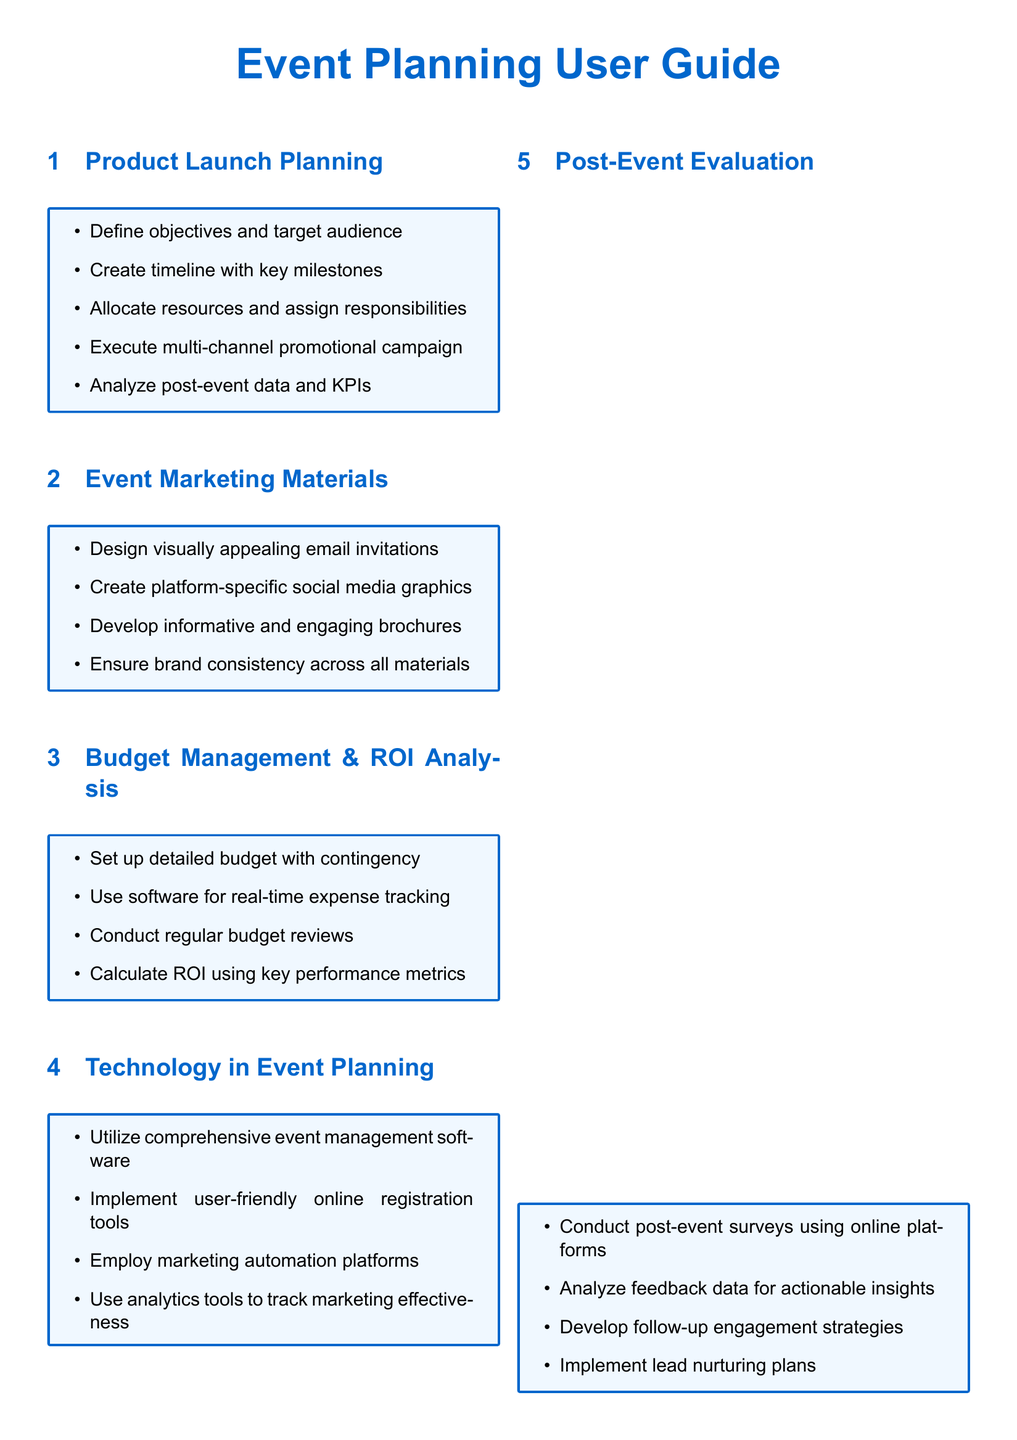What are the critical phases of planning a product launch event? The critical phases include defining objectives and target audience, creating a timeline with key milestones, allocating resources and assigning responsibilities, executing a multi-channel promotional campaign, and analyzing post-event data and KPIs.
Answer: Define objectives and target audience, create timeline with key milestones, allocate resources and assign responsibilities, execute multi-channel promotional campaign, analyze post-event data and KPIs What should be included in effective event marketing materials? Effective event marketing materials should include visually appealing email invitations, platform-specific social media graphics, informative brochures, and ensure brand consistency across all materials.
Answer: Visually appealing email invitations, platform-specific social media graphics, informative brochures, brand consistency What is a key aspect of budget management for corporate events? A key aspect of budget management is setting up a detailed budget with contingencies to manage unexpected expenses.
Answer: Setting up a detailed budget with contingency Which software tools can enhance event planning? Comprehensive event management software, user-friendly online registration tools, marketing automation platforms, and analytics tools are useful for enhancing event planning.
Answer: Comprehensive event management software, user-friendly online registration tools, marketing automation platforms, analytics tools How should a marketing manager position event objectives? Event objectives should be aligned with the overall brand positioning to ensure consistency in messaging and brand values.
Answer: Align event objectives with overall brand positioning What is an important follow-up strategy after an event? Conducting post-event surveys using online platforms is important for gathering feedback and insights for future improvements.
Answer: Conducting post-event surveys using online platforms 